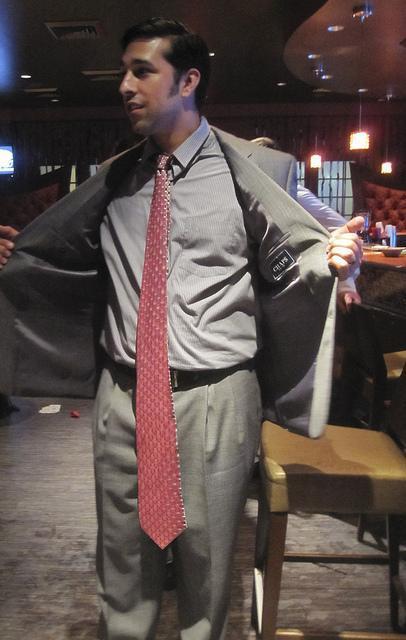What is the problem with this tie?
From the following set of four choices, select the accurate answer to respond to the question.
Options: Too long, too feminine, too bright, too short. Too long. What clothing item is most strangely fitting on this man?
Indicate the correct response by choosing from the four available options to answer the question.
Options: Necktie, belt, shirt, pants. Necktie. 